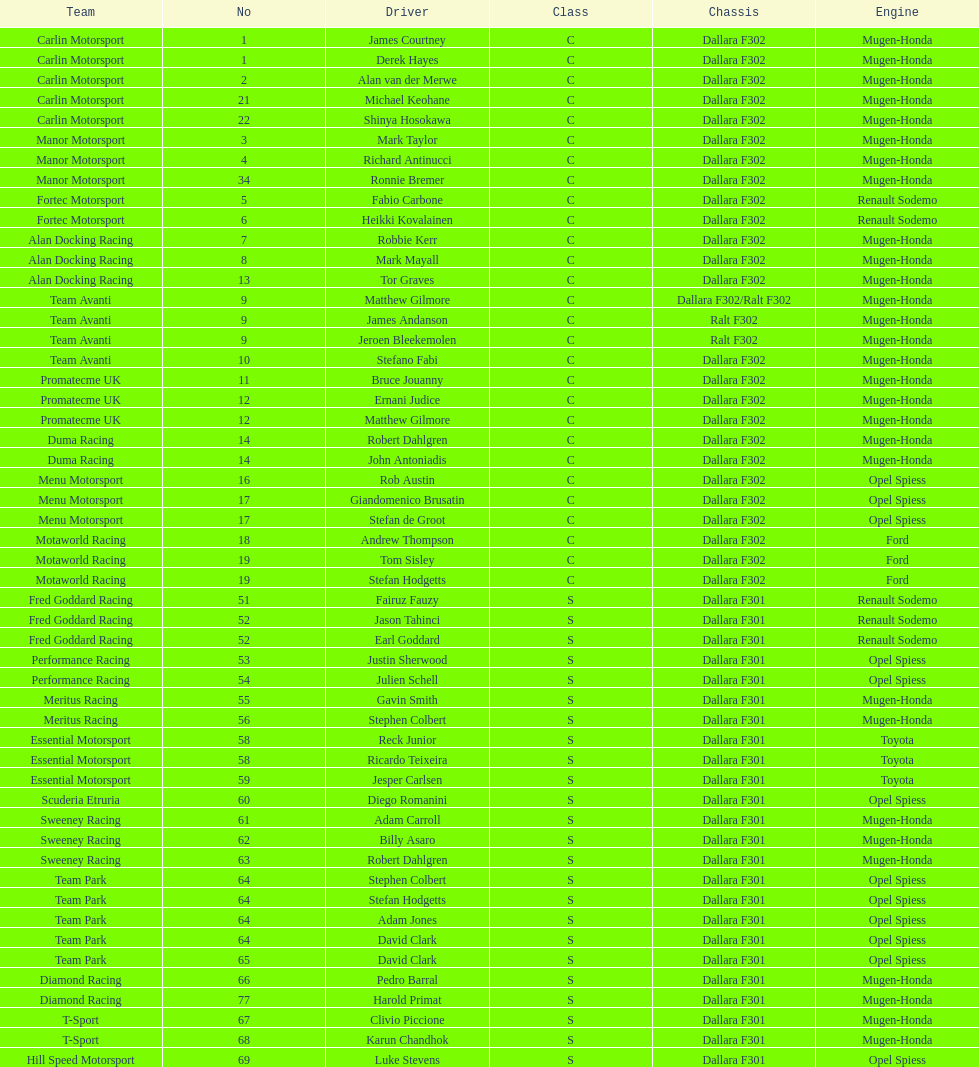Comparing team avanti and motaworld racing, which team had a greater number of drivers? Team Avanti. 